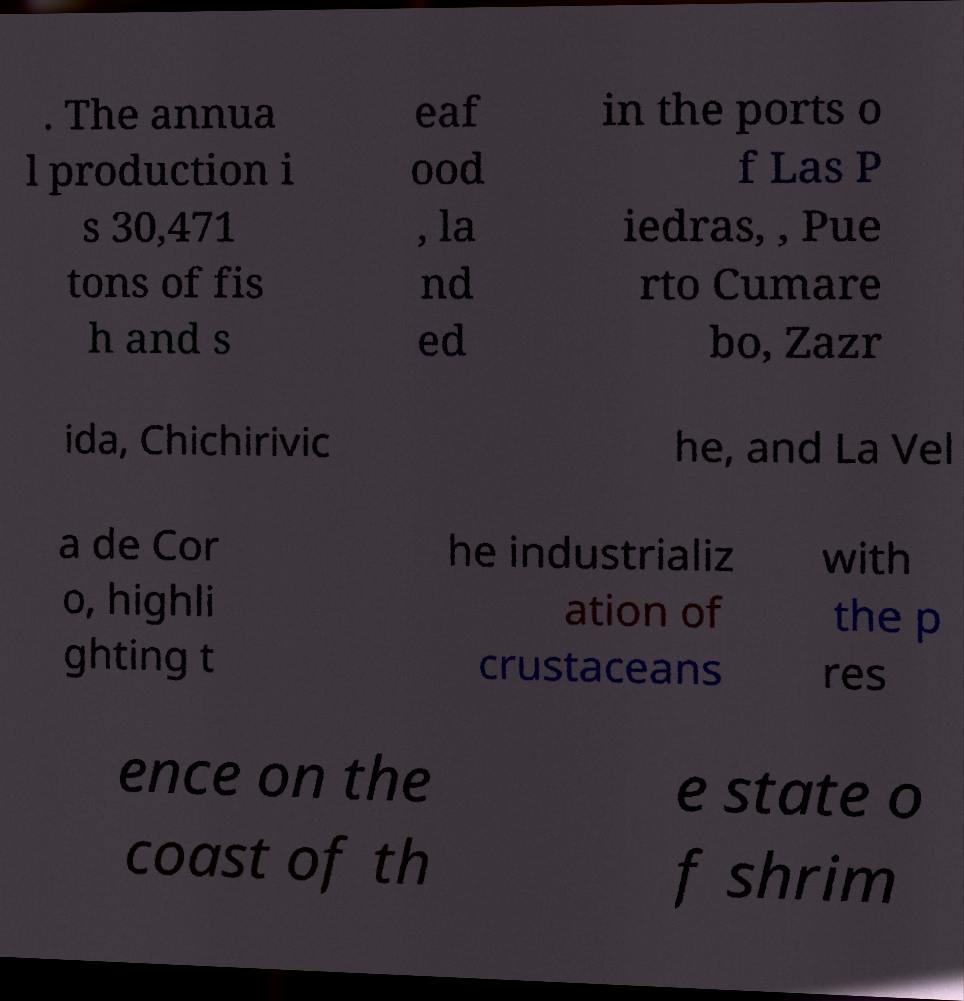Could you assist in decoding the text presented in this image and type it out clearly? . The annua l production i s 30,471 tons of fis h and s eaf ood , la nd ed in the ports o f Las P iedras, , Pue rto Cumare bo, Zazr ida, Chichirivic he, and La Vel a de Cor o, highli ghting t he industrializ ation of crustaceans with the p res ence on the coast of th e state o f shrim 